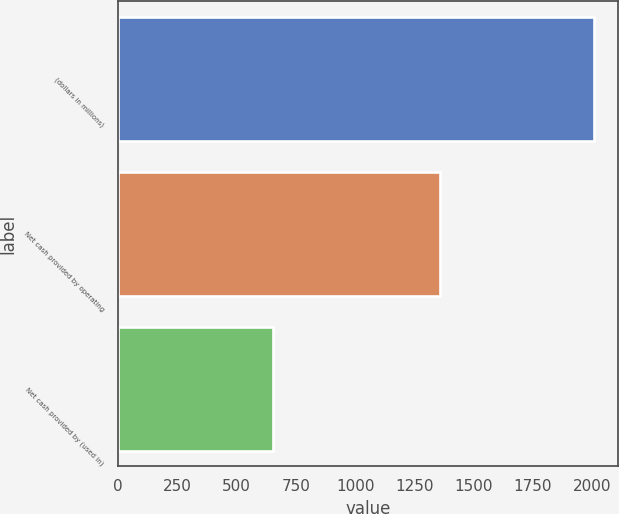<chart> <loc_0><loc_0><loc_500><loc_500><bar_chart><fcel>(dollars in millions)<fcel>Net cash provided by operating<fcel>Net cash provided by (used in)<nl><fcel>2010<fcel>1356.4<fcel>653.4<nl></chart> 